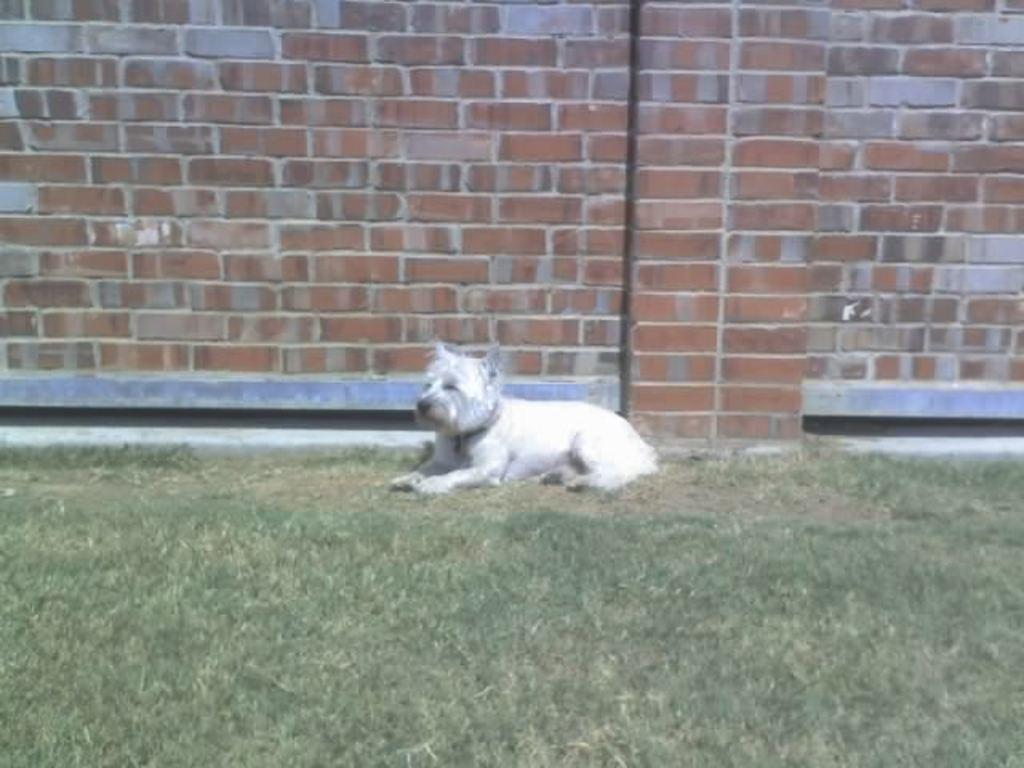Could you give a brief overview of what you see in this image? There is a white dog on the grass. In the background there is a brick wall. 